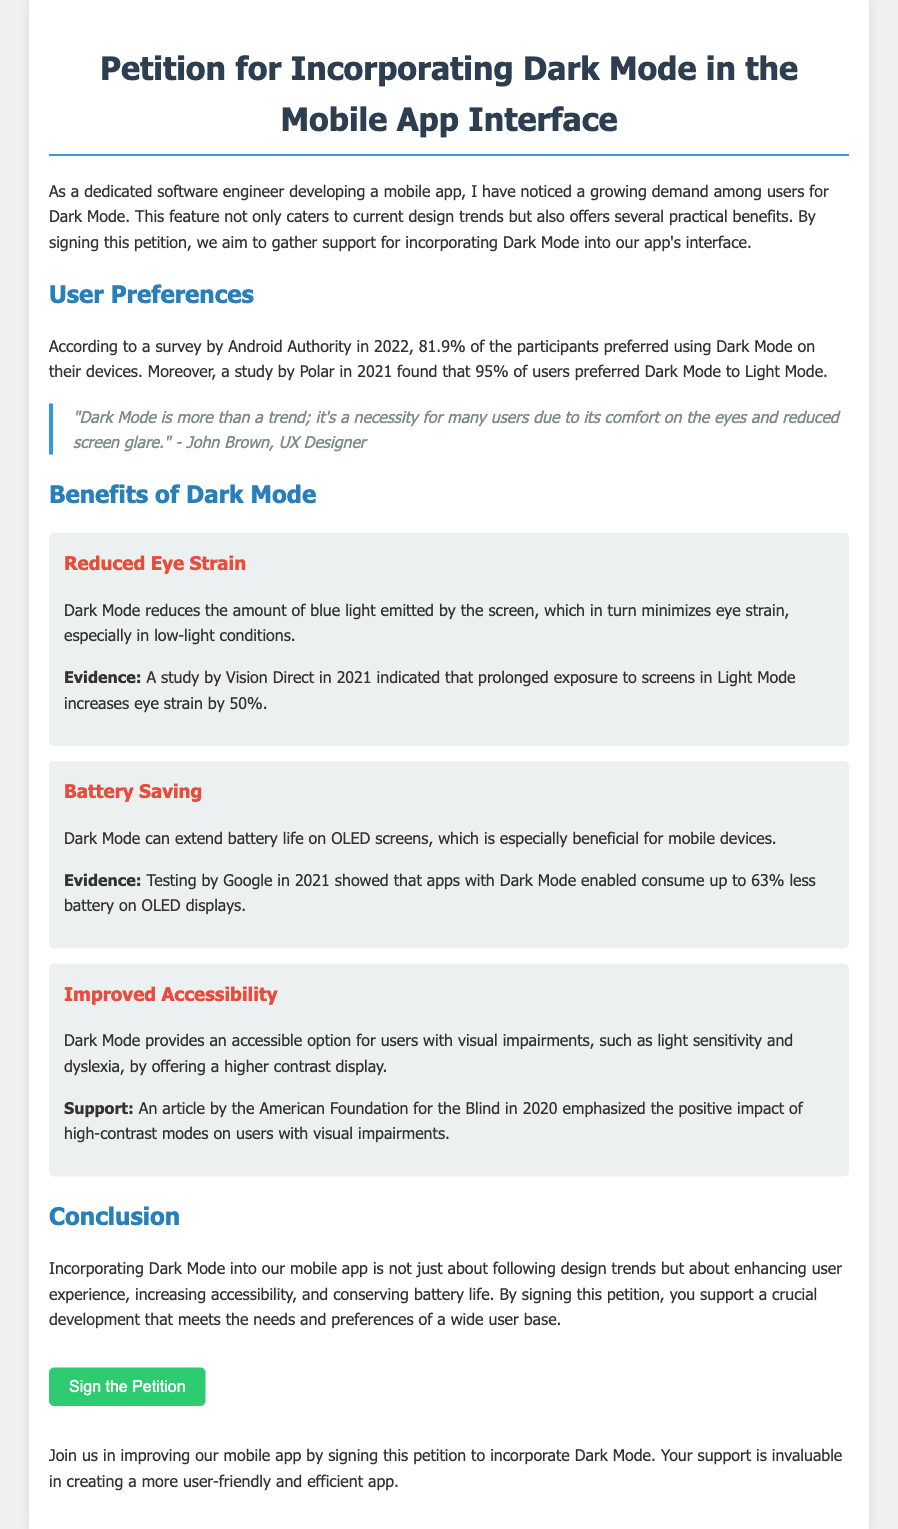What percentage of users preferred Dark Mode according to the survey? The survey by Android Authority in 2022 indicated that 81.9% of participants preferred using Dark Mode on their devices.
Answer: 81.9% What is one significant benefit of Dark Mode mentioned? The document outlines several benefits, one of which is reduced eye strain due to the lower amount of blue light emitted by the screen.
Answer: Reduced eye strain In which year did the study indicating increased eye strain in Light Mode take place? The study by Vision Direct that indicated increased eye strain by 50% in Light Mode was conducted in 2021.
Answer: 2021 What is the name of the UX designer quoted in the document? The quote regarding Dark Mode as a necessity comes from John Brown, a UX Designer.
Answer: John Brown How much less battery can Dark Mode consume on OLED displays according to Google? Testing by Google showed that apps with Dark Mode enabled can consume up to 63% less battery on OLED displays.
Answer: 63% What kind of users benefit from improved accessibility in Dark Mode? The document mentions that users with visual impairments, such as light sensitivity and dyslexia, benefit from the high contrast display provided by Dark Mode.
Answer: Users with visual impairments What call to action is presented at the end of the document? The document encourages readers to support the incorporation of Dark Mode by signing the petition, which is a direct action request.
Answer: Sign the Petition Which organization highlighted the positive impact of high-contrast modes? An article by the American Foundation for the Blind in 2020 emphasized the benefits of high-contrast modes on users with visual impairments.
Answer: American Foundation for the Blind 